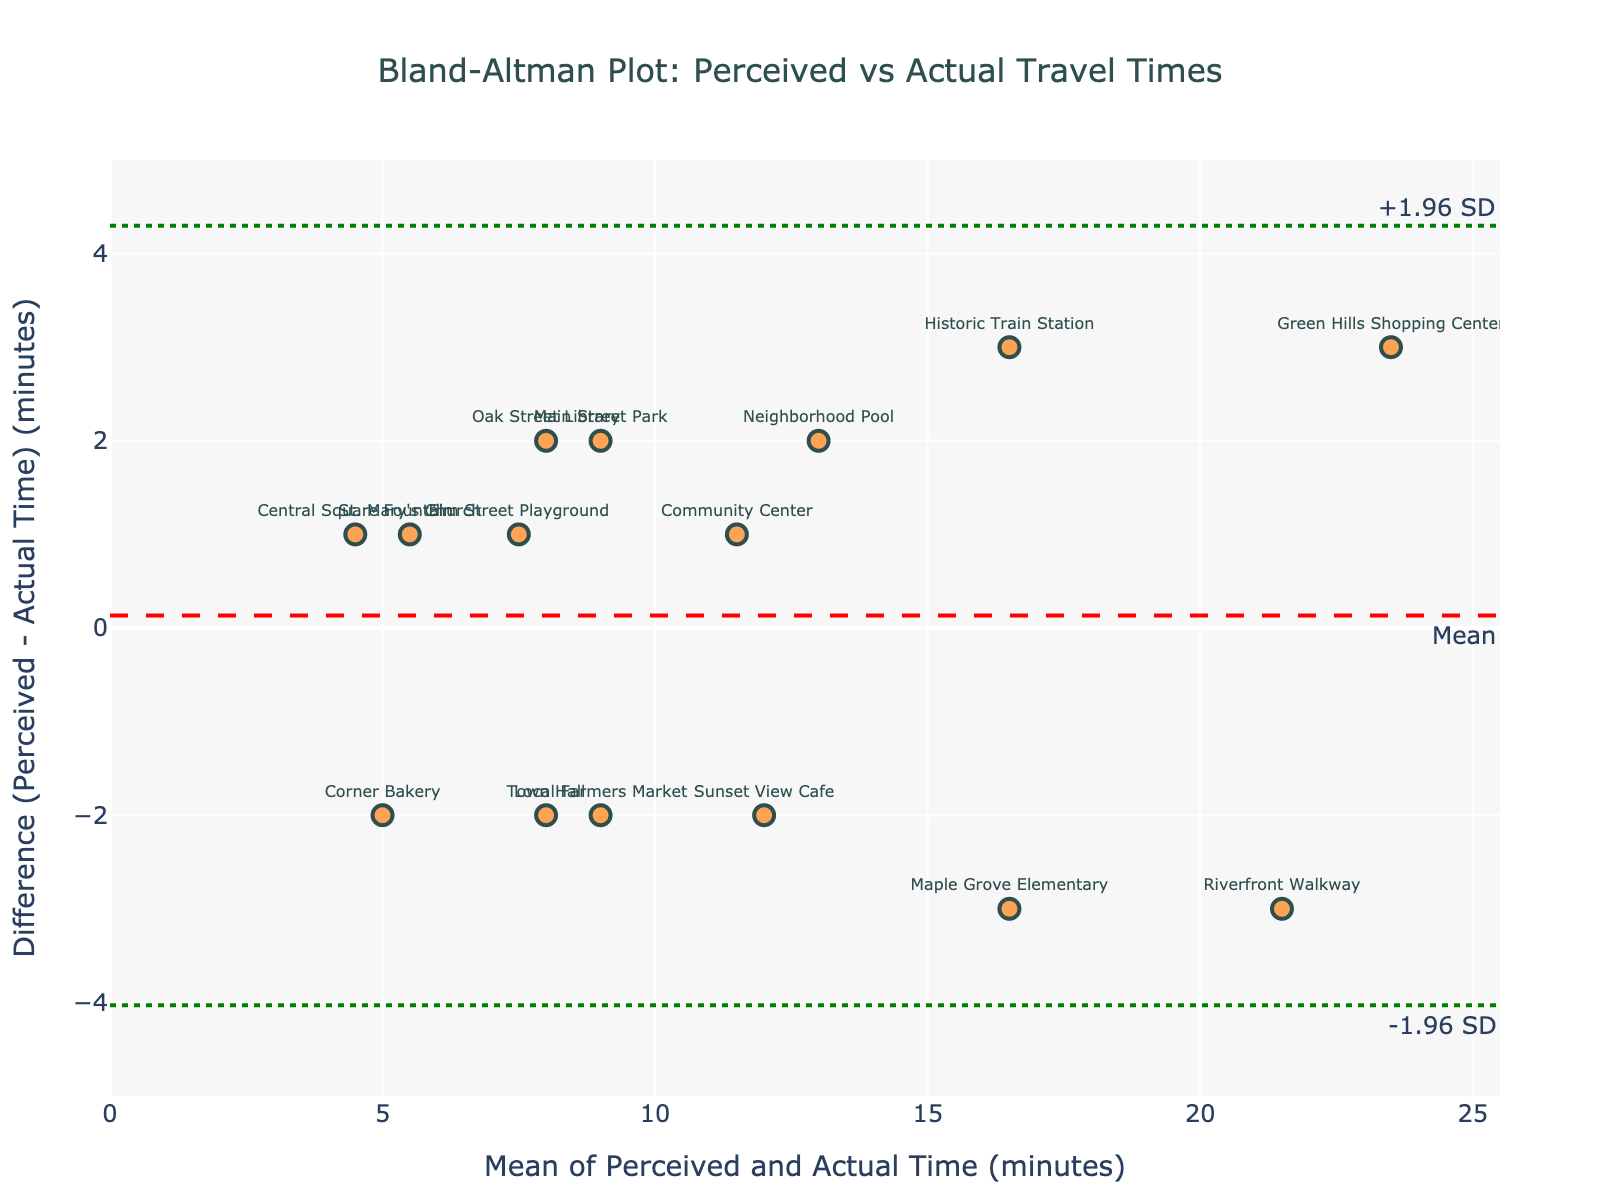How many landmarks are plotted in the Bland-Altman plot? To find the number of landmarks, count the data points displayed on the plot. Each point corresponds to a landmark.
Answer: 15 What is the title of the Bland-Altman plot? The title is usually positioned at the top center of the plot.
Answer: Bland-Altman Plot: Perceived vs Actual Travel Times Which landmark has the highest positive perceived travel time difference compared to actual travel time? Identify the data point with the highest vertical position above the horizontal axis, where the perceived time is greater than the actual time. Look at the label next to this data point.
Answer: Elm Street Playground What is the range of the mean of perceived and actual travel times depicted on the x-axis? The x-axis represents the mean of perceived and actual times. Review the minimum and maximum values on the x-axis to find the range.
Answer: 4 to 23.5 What are the upper and lower limits of agreement on the plot? These are indicated by the dashed lines labeled as "+1.96 SD" and "-1.96 SD". Find the corresponding y-values for these lines.
Answer: +4.524 and -3.591 By how many minutes does the perceived time for the Historic Train Station differ from its actual time? Identify the y-value for the data point labeled "Historic Train Station" which will give the difference.
Answer: 3 Is the mean perceived time generally longer or shorter compared to the actual time in this neighborhood? Observe the overall placement of data points above and below the mean line. If more points are above, perceived time is generally longer; if below, shorter.
Answer: Longer How many landmarks have a perceived time exactly equal to their actual time? Count the number of data points that have a zero difference (y=0) on the plot.
Answer: 0 Which landmark has the smallest negative perceived time difference compared to the actual time? Determine the data point with the lowest but non-zero negative value on the vertical axis and read its corresponding label.
Answer: Main Street Park What is the standard deviation of the differences in perceived and actual travel times displayed on the plot? The standard deviation is used to calculate the limits of agreement. Use the distances of these lines from the mean difference line to infer the standard deviation. The exact value requires further calculation not provided directly in the plot, but given: upper_loa = mean_diff + 1.96 * std_diff and lower_loa = mean_diff - 1.96 * std_diff, you can extract the mean_diff from the middle line and solve for std_diff.
Answer: 2.099 